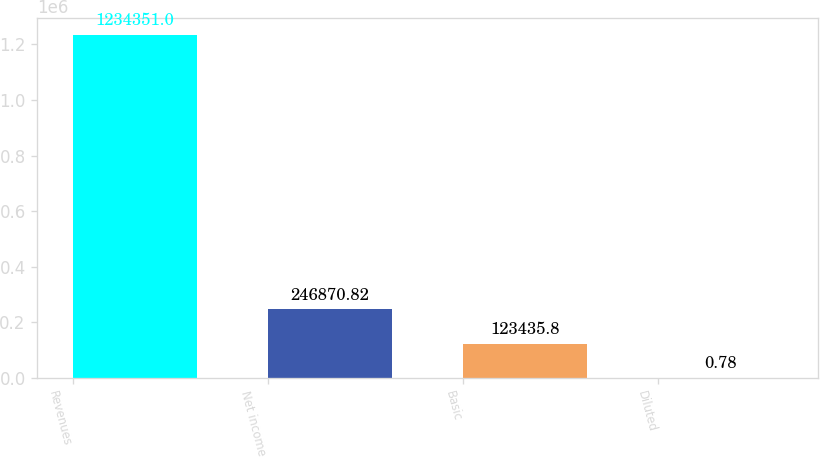Convert chart. <chart><loc_0><loc_0><loc_500><loc_500><bar_chart><fcel>Revenues<fcel>Net income<fcel>Basic<fcel>Diluted<nl><fcel>1.23435e+06<fcel>246871<fcel>123436<fcel>0.78<nl></chart> 